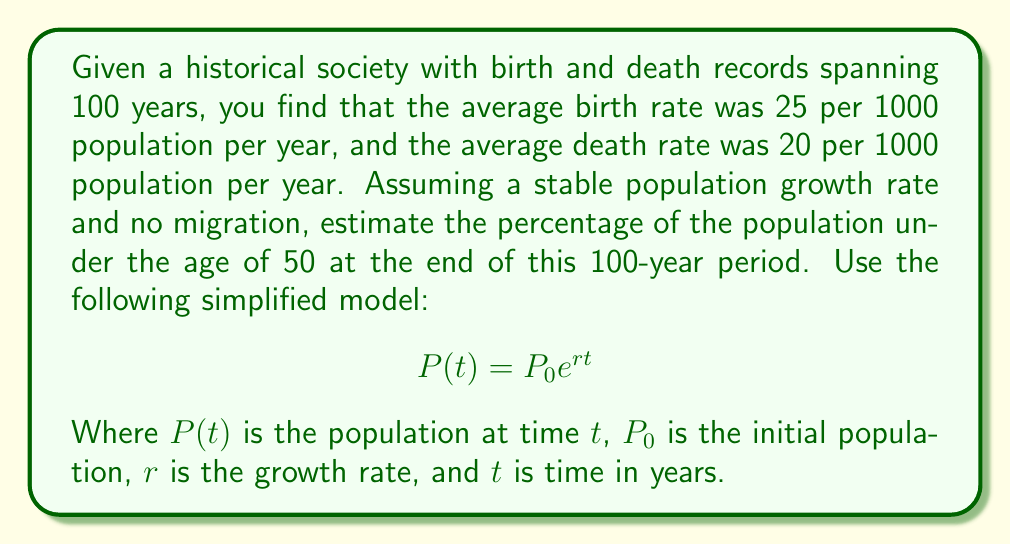Could you help me with this problem? To solve this inverse problem, we'll follow these steps:

1. Calculate the growth rate:
   The growth rate $r$ is the difference between birth rate and death rate.
   $r = (25 - 20) / 1000 = 0.005$ or 0.5% per year

2. Use the growth rate to estimate the population distribution:
   In a stable population with constant growth rate, the age distribution follows an exponential decay function.

3. Calculate the proportion under 50:
   The proportion of the population under age $x$ is given by:
   $$ F(x) = 1 - e^{-rx} $$

   For age 50:
   $$ F(50) = 1 - e^{-0.005 * 50} $$

4. Solve the equation:
   $$ F(50) = 1 - e^{-0.25} $$
   $$ F(50) = 1 - 0.7788 $$
   $$ F(50) = 0.2212 $$

5. Convert to percentage:
   0.2212 * 100 = 22.12%

Therefore, approximately 22.12% of the population is estimated to be under the age of 50 at the end of the 100-year period.
Answer: 22.12% 